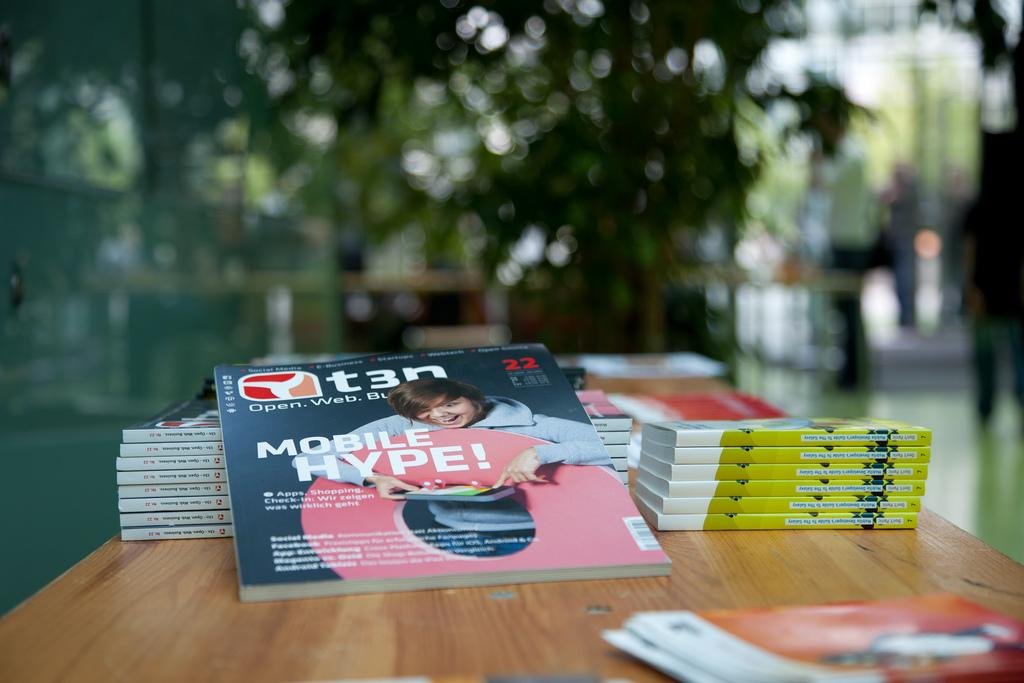What objects are on the table in the image? There are books on the table in the image. What type of natural element can be seen in the image? There is a tree visible in the image. Can you describe the person in the image? The image contains a person, but no specific details about their appearance or actions are provided. What type of can is being used by the person in the image? There is no can present in the image; the person is not using any can. How many wool sweaters is the person wearing in the image? There is no information about the person's clothing in the image, so we cannot determine if they are wearing any wool sweaters. 